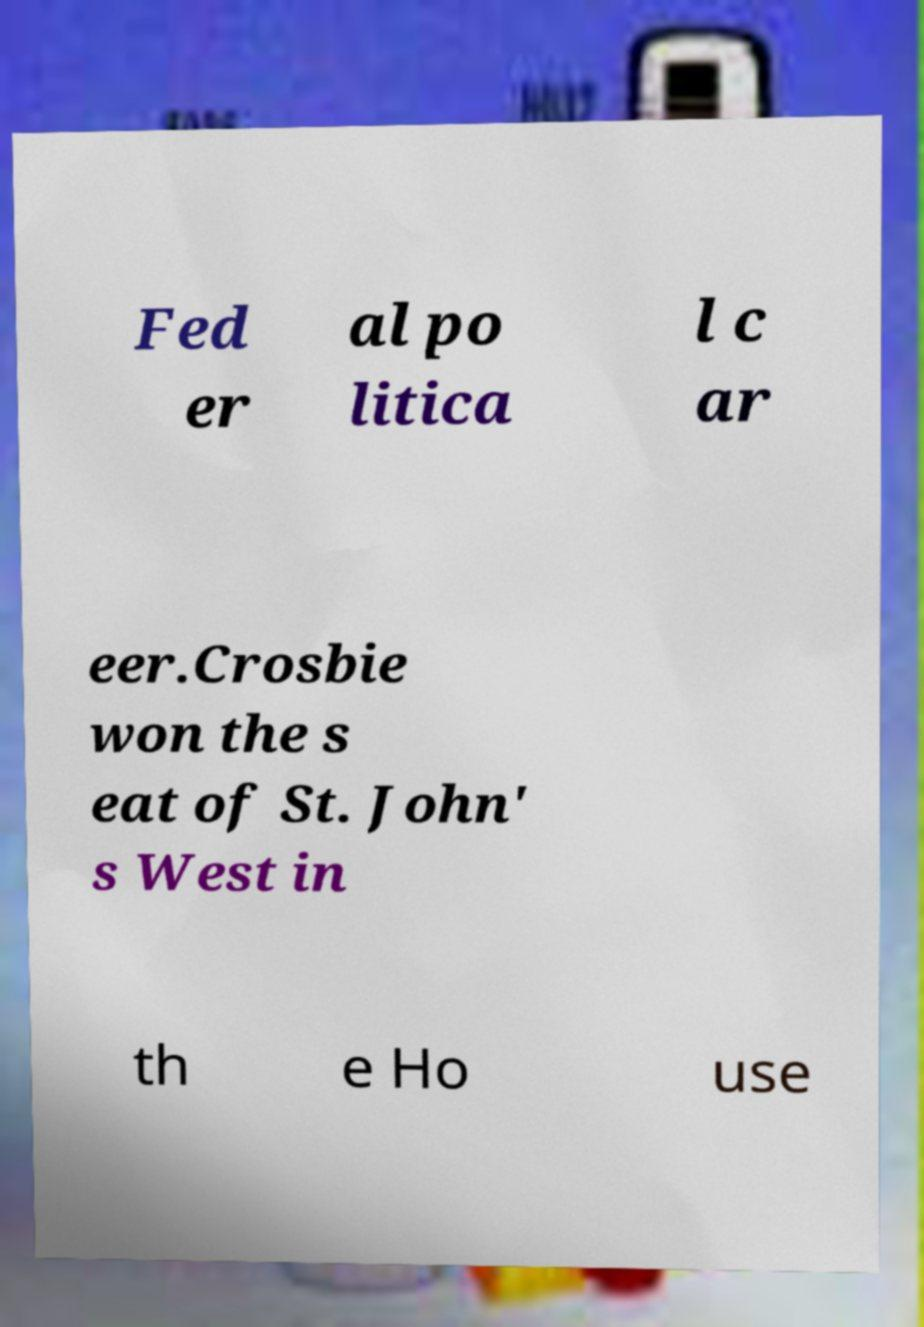For documentation purposes, I need the text within this image transcribed. Could you provide that? Fed er al po litica l c ar eer.Crosbie won the s eat of St. John' s West in th e Ho use 